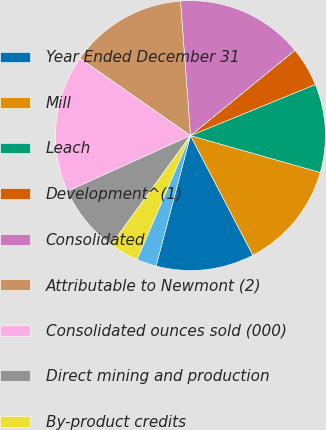<chart> <loc_0><loc_0><loc_500><loc_500><pie_chart><fcel>Year Ended December 31<fcel>Mill<fcel>Leach<fcel>Development^(1)<fcel>Consolidated<fcel>Attributable to Newmont (2)<fcel>Consolidated ounces sold (000)<fcel>Direct mining and production<fcel>By-product credits<fcel>Royalties and production taxes<nl><fcel>11.76%<fcel>12.94%<fcel>10.59%<fcel>4.71%<fcel>15.29%<fcel>14.12%<fcel>16.47%<fcel>8.24%<fcel>3.53%<fcel>2.36%<nl></chart> 